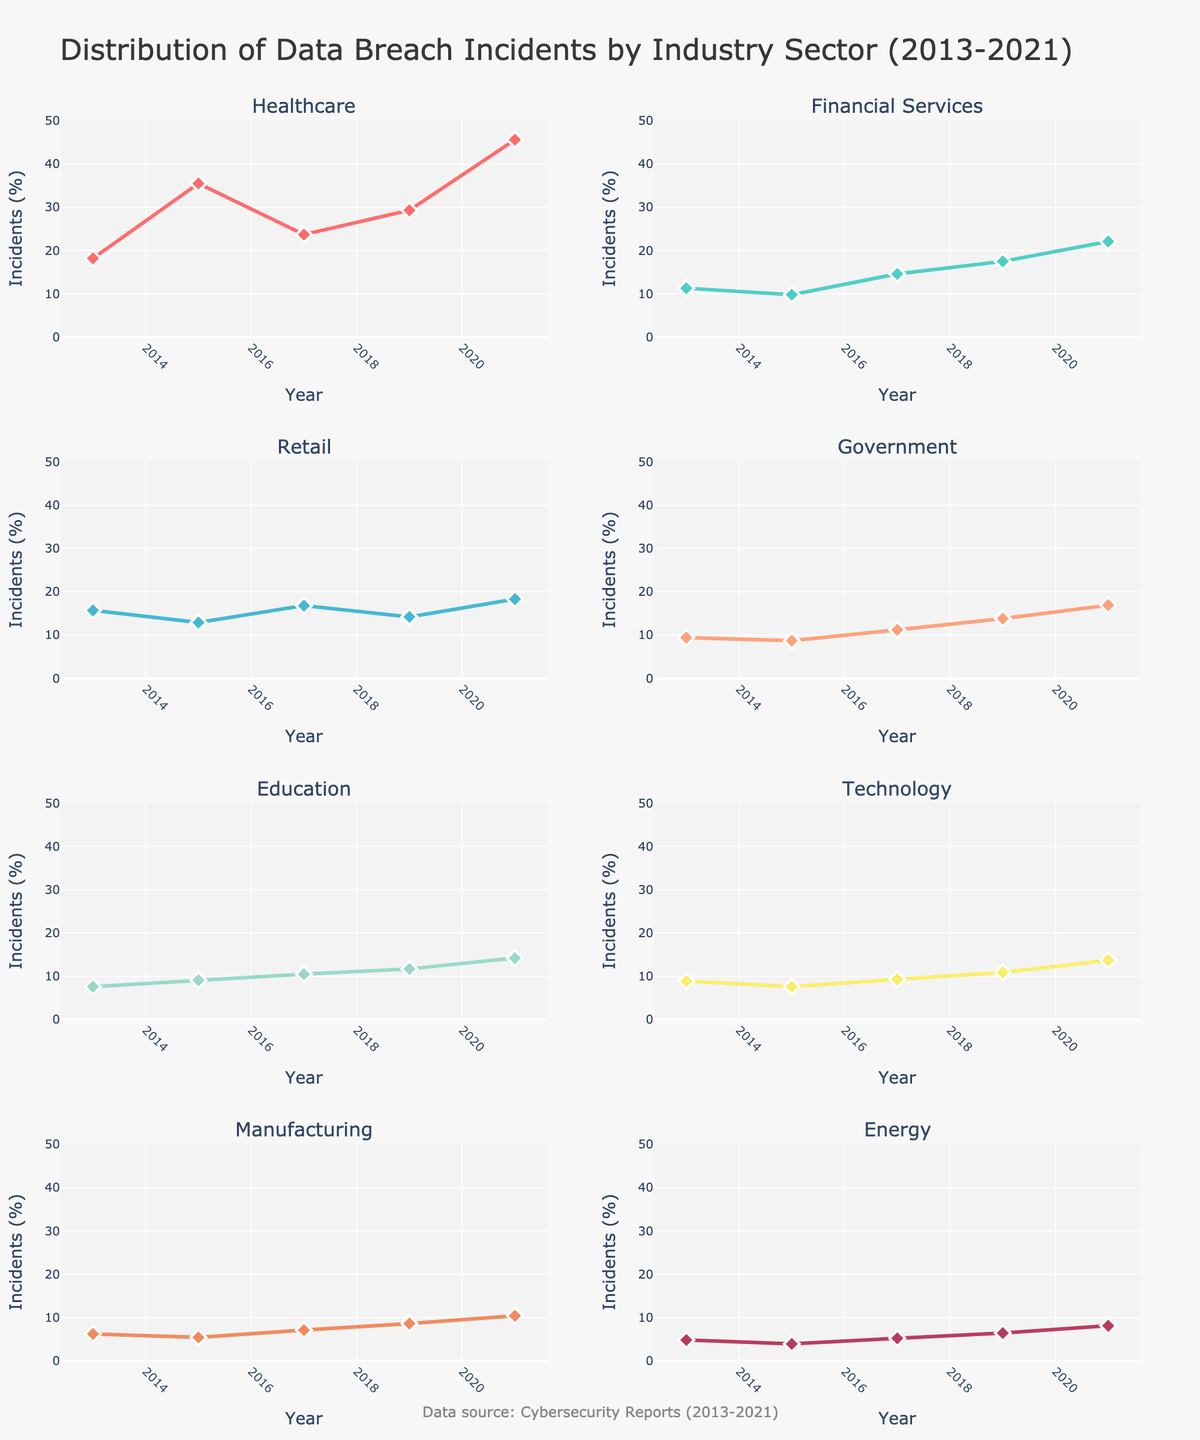What is the title of the figure? The title of the figure is usually located at the top and summarizes the main topic. By reading the highest text on the figure, we see the title "Distribution of Data Breach Incidents by Industry Sector (2013-2021)"
Answer: Distribution of Data Breach Incidents by Industry Sector (2013-2021) Which industry sector had the highest percentage of data breach incidents in 2021? The specific values for each industry sector in 2021 can be seen at the rightmost end of each subplot. By examining the last data points, Healthcare has the highest percentage at 45.6%
Answer: Healthcare How many subplots are there in the figure? The figure consists of visual components arranged in a grid. By counting the number of these visual components, we see there are 8 subplots, each corresponding to an industry
Answer: 8 Which industry showed the least percentage of data breach incidents in 2013 and what was that percentage? To find this, we need to look at the values for 2013 in each subplot. The lowest percentage in 2013 was for the Energy industry at 4.8%
Answer: Energy, 4.8% Between which two years did the Healthcare industry see the largest increase in data breach incidents percentage-wise? By examining the Healthcare subplot, we see the yearly percentages. The largest increase is between 2019 (29.3%) and 2021 (45.6%). The increase is 45.6 - 29.3 = 16.3%
Answer: 2019 and 2021 Compare the percentage of data breach incidents in the Financial Services industry for the years 2015 and 2017. Which year had a higher percentage and by how much? Financial Services subplot shows values for 2015 (9.8%) and 2017 (14.6%). The difference is 14.6 - 9.8 = 4.8, with 2017 having a higher percentage
Answer: 2017, 4.8% What is the overall trend in data breach incidents for the Retail industry from 2013 to 2021? Examining the Retail subplot and following the trend line from 2013 (15.7%) to 2021 (18.3%), we see slight fluctuations, but overall, it maintains a small upward trend
Answer: Slight upward trend Which two industries had the closest percentage of data breach incidents in 2019, and what were their percentages? Looking at the percentages for 2019 in the subplots, the closest values are for Financial Services (17.5%) and Government (13.8%)
Answer: Financial Services (17.5%) and Government (13.8%) Calculate the average percentage of data breach incidents for the Technology industry over the five years provided. The percentages for the Technology industry are 8.9 (2013), 7.6 (2015), 9.3 (2017), 10.9 (2019), and 13.7 (2021). Sum these up: (8.9 + 7.6 + 9.3 + 10.9 + 13.7) = 50.4. Divide by 5 gives the average: 50.4 / 5 = 10.08%
Answer: 10.08% 